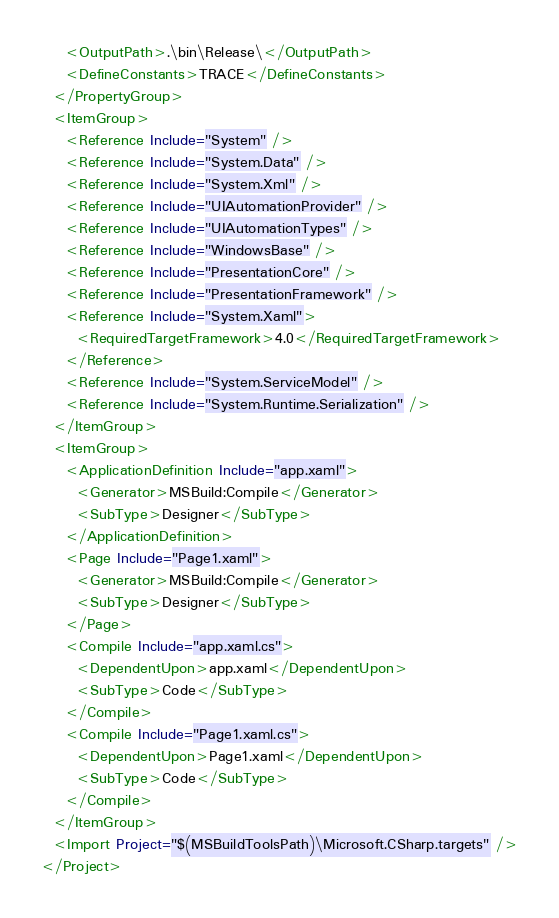Convert code to text. <code><loc_0><loc_0><loc_500><loc_500><_XML_>    <OutputPath>.\bin\Release\</OutputPath>
    <DefineConstants>TRACE</DefineConstants>
  </PropertyGroup>
  <ItemGroup>
    <Reference Include="System" />
    <Reference Include="System.Data" />
    <Reference Include="System.Xml" />
    <Reference Include="UIAutomationProvider" />
    <Reference Include="UIAutomationTypes" />
    <Reference Include="WindowsBase" />
    <Reference Include="PresentationCore" />
    <Reference Include="PresentationFramework" />
    <Reference Include="System.Xaml">
      <RequiredTargetFramework>4.0</RequiredTargetFramework>
    </Reference>
    <Reference Include="System.ServiceModel" />
    <Reference Include="System.Runtime.Serialization" />
  </ItemGroup>
  <ItemGroup>
    <ApplicationDefinition Include="app.xaml">
      <Generator>MSBuild:Compile</Generator>
      <SubType>Designer</SubType>
    </ApplicationDefinition>
    <Page Include="Page1.xaml">
      <Generator>MSBuild:Compile</Generator>
      <SubType>Designer</SubType>
    </Page>
    <Compile Include="app.xaml.cs">
      <DependentUpon>app.xaml</DependentUpon>
      <SubType>Code</SubType>
    </Compile>
    <Compile Include="Page1.xaml.cs">
      <DependentUpon>Page1.xaml</DependentUpon>
      <SubType>Code</SubType>
    </Compile>
  </ItemGroup>
  <Import Project="$(MSBuildToolsPath)\Microsoft.CSharp.targets" />
</Project></code> 